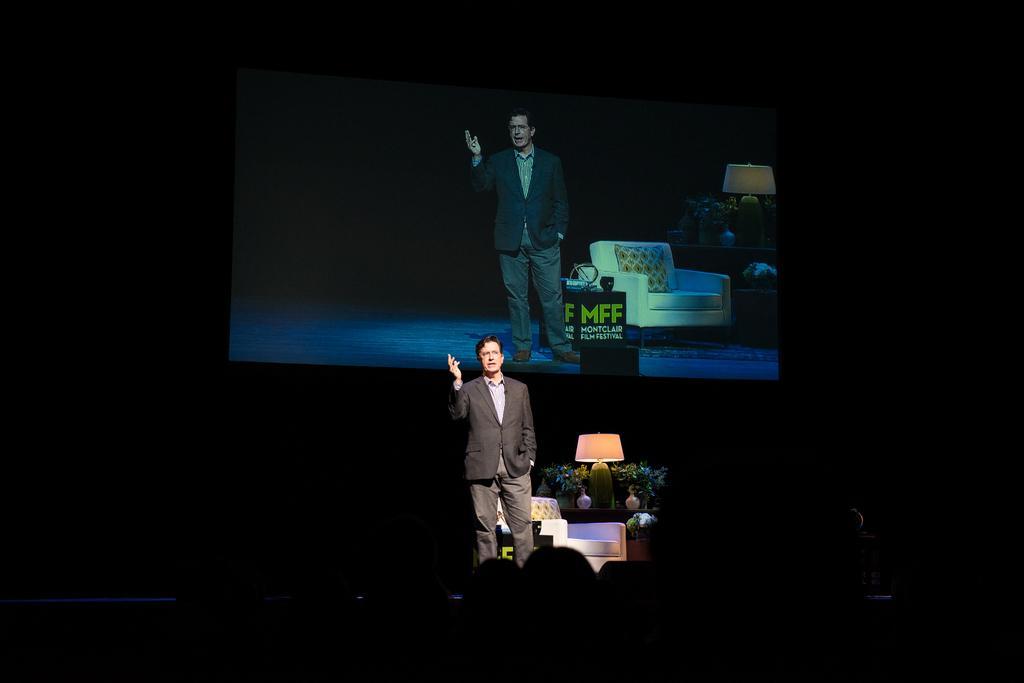Can you describe this image briefly? In this image there is a person speaking on the stage, behind him there are few flower pots, a light on the table, a chair, there is a screen on the screen there is a person and few objects on the tables. 